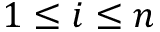<formula> <loc_0><loc_0><loc_500><loc_500>1 \leq i \leq n</formula> 